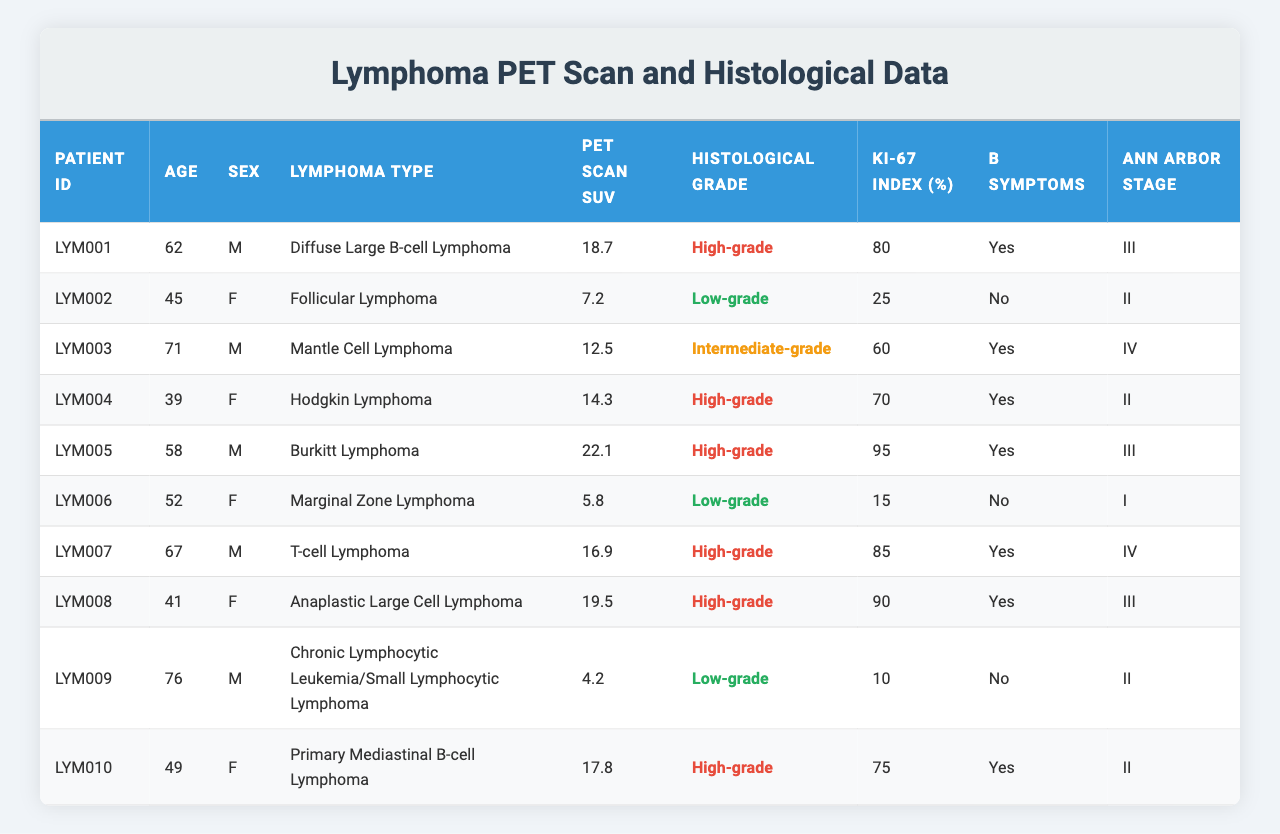What is the PET Scan SUV value for Patient LYM005? The patient's row shows that the PET Scan SUV value for LYM005 is 22.1.
Answer: 22.1 Which lymphoma type has the highest Ki-67 Index? The highest Ki-67 Index is 95%, found in Burkitt Lymphoma (LYM005).
Answer: 95% How many patients have high-grade lymphoma? By counting the rows labeled as "High-grade," there are 5 patients with high-grade lymphoma.
Answer: 5 What is the average PET Scan SUV value for low-grade lymphoma patients? The PET Scan SUV values for low-grade patients (LYM002, LYM006, LYM009) are 7.2, 5.8, and 4.2. Sum = 17.2; average = 17.2/3 = 5.73.
Answer: 5.73 Is there a patient with low-grade lymphoma who also exhibits B Symptoms? Checking the entries, both low-grade lymphoma patients (LYM002, LYM006, LYM009) do not report B Symptoms.
Answer: No What is the difference in PET scan SUV values between the highest and lowest SUV of patients? The highest PET Scan SUV is 22.1 (LYM005) and the lowest is 4.2 (LYM009). The difference is 22.1 - 4.2 = 17.9.
Answer: 17.9 Which patient has the lowest Ki-67 index, and what is its value? LYM009 has the lowest Ki-67 Index at 10%.
Answer: 10% How many male patients have high-grade lymphoma? The male patients with high-grade lymphoma are LYM001, LYM005, LYM007, and LYM008, totaling 4 patients.
Answer: 4 What is the Ann Arbor stage of the patient with the highest PET scan SUV? The patient LYM005 has the highest PET scan SUV of 22.1 and is at Ann Arbor Stage III.
Answer: III Are there any patients with low-grade lymphoma in Ann Arbor Stage I? Only LYM006 is a low-grade lymphoma patient, and they are at Ann Arbor Stage I.
Answer: Yes 